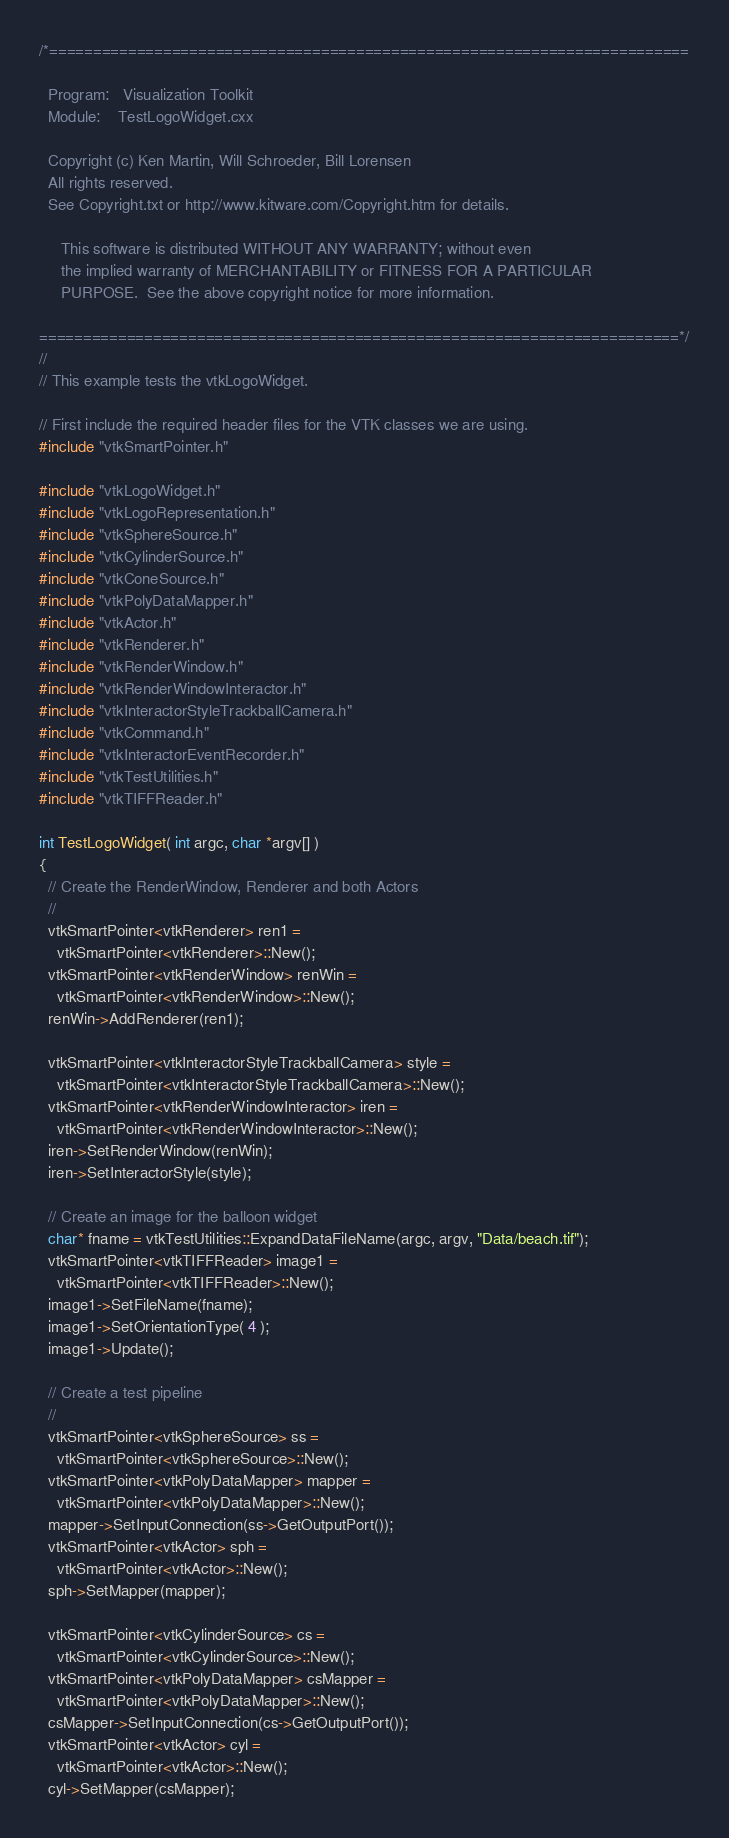Convert code to text. <code><loc_0><loc_0><loc_500><loc_500><_C++_>/*=========================================================================

  Program:   Visualization Toolkit
  Module:    TestLogoWidget.cxx

  Copyright (c) Ken Martin, Will Schroeder, Bill Lorensen
  All rights reserved.
  See Copyright.txt or http://www.kitware.com/Copyright.htm for details.

     This software is distributed WITHOUT ANY WARRANTY; without even
     the implied warranty of MERCHANTABILITY or FITNESS FOR A PARTICULAR
     PURPOSE.  See the above copyright notice for more information.

=========================================================================*/
//
// This example tests the vtkLogoWidget.

// First include the required header files for the VTK classes we are using.
#include "vtkSmartPointer.h"

#include "vtkLogoWidget.h"
#include "vtkLogoRepresentation.h"
#include "vtkSphereSource.h"
#include "vtkCylinderSource.h"
#include "vtkConeSource.h"
#include "vtkPolyDataMapper.h"
#include "vtkActor.h"
#include "vtkRenderer.h"
#include "vtkRenderWindow.h"
#include "vtkRenderWindowInteractor.h"
#include "vtkInteractorStyleTrackballCamera.h"
#include "vtkCommand.h"
#include "vtkInteractorEventRecorder.h"
#include "vtkTestUtilities.h"
#include "vtkTIFFReader.h"

int TestLogoWidget( int argc, char *argv[] )
{
  // Create the RenderWindow, Renderer and both Actors
  //
  vtkSmartPointer<vtkRenderer> ren1 =
    vtkSmartPointer<vtkRenderer>::New();
  vtkSmartPointer<vtkRenderWindow> renWin =
    vtkSmartPointer<vtkRenderWindow>::New();
  renWin->AddRenderer(ren1);

  vtkSmartPointer<vtkInteractorStyleTrackballCamera> style =
    vtkSmartPointer<vtkInteractorStyleTrackballCamera>::New();
  vtkSmartPointer<vtkRenderWindowInteractor> iren =
    vtkSmartPointer<vtkRenderWindowInteractor>::New();
  iren->SetRenderWindow(renWin);
  iren->SetInteractorStyle(style);

  // Create an image for the balloon widget
  char* fname = vtkTestUtilities::ExpandDataFileName(argc, argv, "Data/beach.tif");
  vtkSmartPointer<vtkTIFFReader> image1 =
    vtkSmartPointer<vtkTIFFReader>::New();
  image1->SetFileName(fname);
  image1->SetOrientationType( 4 );
  image1->Update();

  // Create a test pipeline
  //
  vtkSmartPointer<vtkSphereSource> ss =
    vtkSmartPointer<vtkSphereSource>::New();
  vtkSmartPointer<vtkPolyDataMapper> mapper =
    vtkSmartPointer<vtkPolyDataMapper>::New();
  mapper->SetInputConnection(ss->GetOutputPort());
  vtkSmartPointer<vtkActor> sph =
    vtkSmartPointer<vtkActor>::New();
  sph->SetMapper(mapper);

  vtkSmartPointer<vtkCylinderSource> cs =
    vtkSmartPointer<vtkCylinderSource>::New();
  vtkSmartPointer<vtkPolyDataMapper> csMapper =
    vtkSmartPointer<vtkPolyDataMapper>::New();
  csMapper->SetInputConnection(cs->GetOutputPort());
  vtkSmartPointer<vtkActor> cyl =
    vtkSmartPointer<vtkActor>::New();
  cyl->SetMapper(csMapper);</code> 